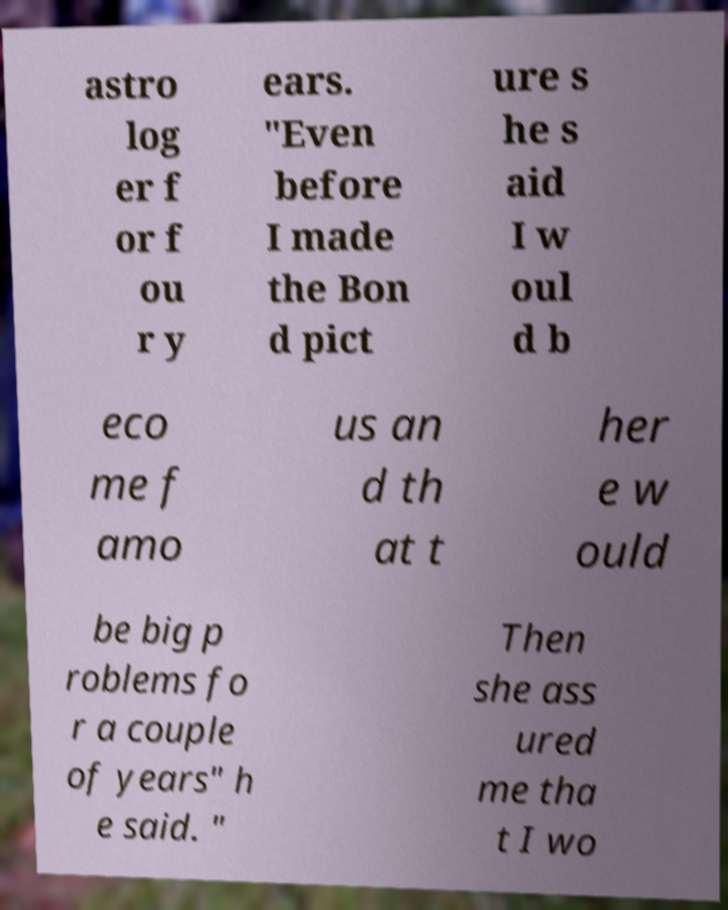Please identify and transcribe the text found in this image. astro log er f or f ou r y ears. "Even before I made the Bon d pict ure s he s aid I w oul d b eco me f amo us an d th at t her e w ould be big p roblems fo r a couple of years" h e said. " Then she ass ured me tha t I wo 